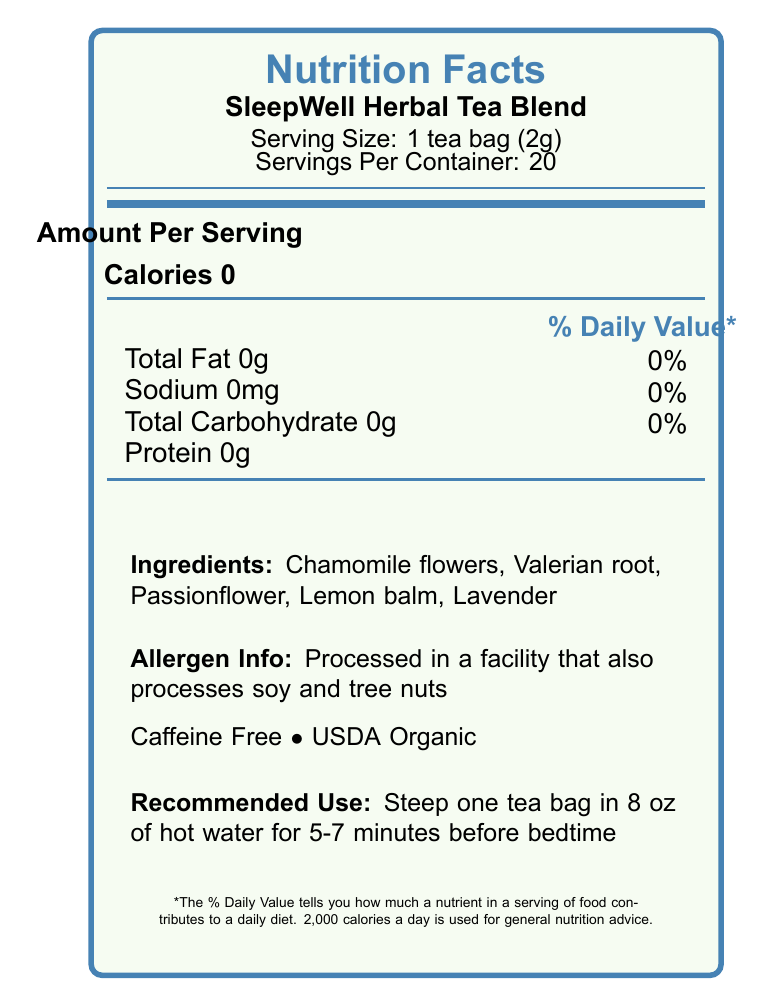what is the serving size? The serving size is listed as 1 tea bag, which weighs 2 grams.
Answer: 1 tea bag (2g) how many servings are in a container? The document states that there are 20 servings per container.
Answer: 20 servings does the product contain any fat or sodium? Both total fat and sodium are listed as 0g and 0mg respectively, with 0% daily value.
Answer: No what are the main ingredients? The primary ingredients are listed as chamomile flowers, valerian root, passionflower, lemon balm, and lavender.
Answer: Chamomile flowers, Valerian root, Passionflower, Lemon balm, Lavender is this product caffeine-free? The document clearly mentions that the product is caffeine-free.
Answer: Yes does the product have any calories? The document states that there are 0 calories per serving.
Answer: No which nutrient is present in the highest amount per serving? The document lists 0g for protein, fat, and carbohydrates, so it's impossible to determine which has the highest amount.
Answer: Cannot be determined what is the recommended use for this product? The document provides specific instructions for steeping the tea bag in hot water for the best results.
Answer: Steep one tea bag in 8 oz of hot water for 5-7 minutes before bedtime how is this product certified? The document indicates that the tea blend has USDA Organic certification.
Answer: USDA Organic which of the following ingredients promotes sleep? A. Lavender B. Chamomile flowers C. Lemon balm The document mentions chamomile as a natural source of apigenin, a flavonoid that promotes sleep.
Answer: B. Chamomile flowers what type of research aligns with this product based on the document? A. Exercise recovery aids B. Cognitive enhancers C. Weight loss aids The document notes that this blend aligns with current research on natural sleep aids and exercise recovery.
Answer: A. Exercise recovery aids is the SleepWell Herbal Tea Blend rich in antioxidants? The document states that the blend is rich in antioxidants that support overall health.
Answer: Yes does the product cater to individuals with soy and tree nut allergies? The document mentions that the product is processed in a facility that also processes soy and tree nuts.
Answer: No summarize the key information of the document The document details the nutritional facts, ingredients, certifications, health benefits, and usage instructions for the SleepWell Herbal Tea Blend, produced by NaturalRest Botanicals.
Answer: The SleepWell Herbal Tea Blend is a caffeine-free, USDA Organic certified herbal tea with 0 calories per serving. It is composed mainly of chamomile flowers, valerian root, passionflower, lemon balm, and lavender. The product is designed to promote sleep and overall health, rich in antioxidants, and aligns with research on natural sleep aids and exercise recovery. Users are advised to steep one tea bag in 8 oz of hot water for 5-7 minutes before bedtime. It is manufactured by NaturalRest Botanicals and has allergen information regarding soy and tree nuts. what is the expiration date of the product? The document specifies that the tea blend expires on June 15, 2025.
Answer: 2025-06-15 what is the daily value percentage of total carbohydrates per serving? The document lists the daily value percentage for total carbohydrates as 0%.
Answer: 0% what is the address of the manufacturer? The document provides the address as 123 Sleepy Hollow Lane, Dreamville, CA 90210.
Answer: 123 Sleepy Hollow Lane, Dreamville, CA 90210 